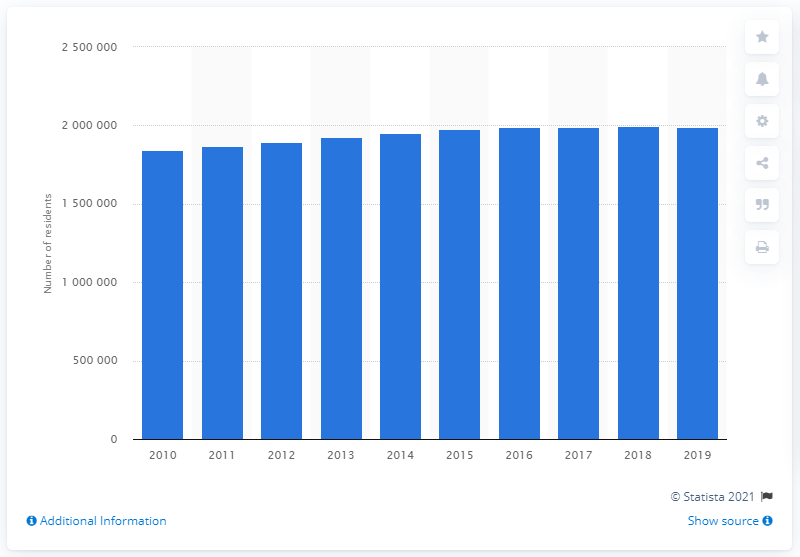Mention a couple of crucial points in this snapshot. In the year 2019, an estimated 197,4501 people lived in the San Jose-Sunnyvale-Santa Clara metropolitan area. 